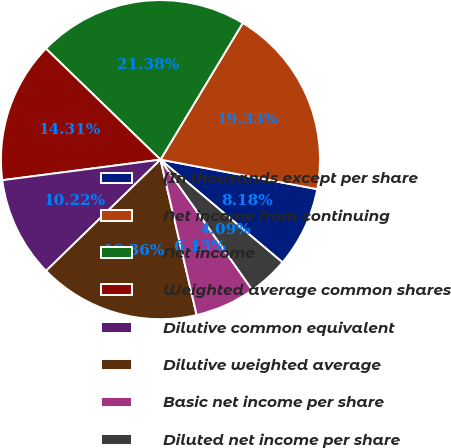<chart> <loc_0><loc_0><loc_500><loc_500><pie_chart><fcel>(In thousands except per share<fcel>Net income from continuing<fcel>Net income<fcel>Weighted average common shares<fcel>Dilutive common equivalent<fcel>Dilutive weighted average<fcel>Basic net income per share<fcel>Diluted net income per share<nl><fcel>8.18%<fcel>19.33%<fcel>21.38%<fcel>14.31%<fcel>10.22%<fcel>16.36%<fcel>6.13%<fcel>4.09%<nl></chart> 